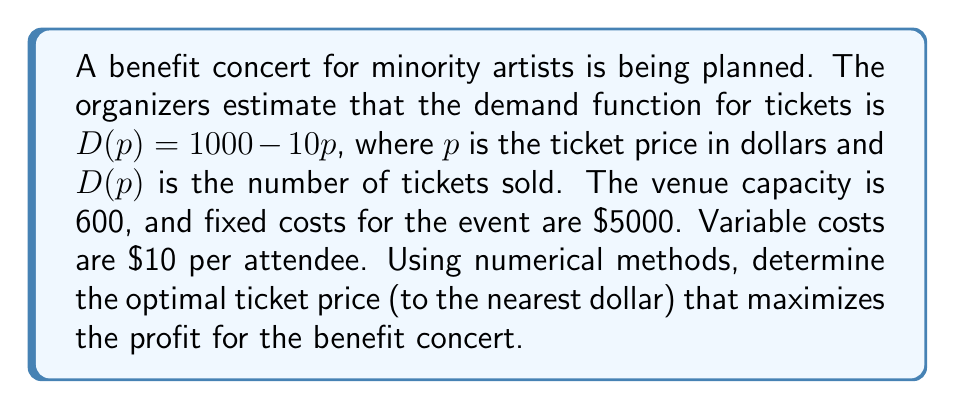Solve this math problem. 1. Define the profit function:
   Profit = Revenue - Costs
   $\Pi(p) = pD(p) - (5000 + 10D(p))$

2. Substitute the demand function:
   $\Pi(p) = p(1000 - 10p) - (5000 + 10(1000 - 10p))$
   $\Pi(p) = 1000p - 10p^2 - 5000 - 10000 + 100p$
   $\Pi(p) = -10p^2 + 1100p - 15000$

3. To find the maximum profit, we need to find the root of the derivative:
   $\frac{d\Pi}{dp} = -20p + 1100$

4. Set the derivative to zero:
   $-20p + 1100 = 0$
   $20p = 1100$
   $p = 55$

5. Verify the second derivative is negative to confirm it's a maximum:
   $\frac{d^2\Pi}{dp^2} = -20 < 0$

6. Check if the optimal price satisfies the venue capacity constraint:
   $D(55) = 1000 - 10(55) = 450 < 600$, so the constraint is satisfied.

7. Round to the nearest dollar:
   Optimal price = $55

8. Calculate the maximum profit:
   $\Pi(55) = -10(55)^2 + 1100(55) - 15000 = 15,125$

Therefore, the optimal ticket price is $55, yielding a maximum profit of $15,125 for the benefit concert.
Answer: $55 